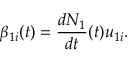<formula> <loc_0><loc_0><loc_500><loc_500>\beta _ { 1 i } ( t ) = \frac { d N _ { 1 } } { d t } ( t ) u _ { 1 i } .</formula> 